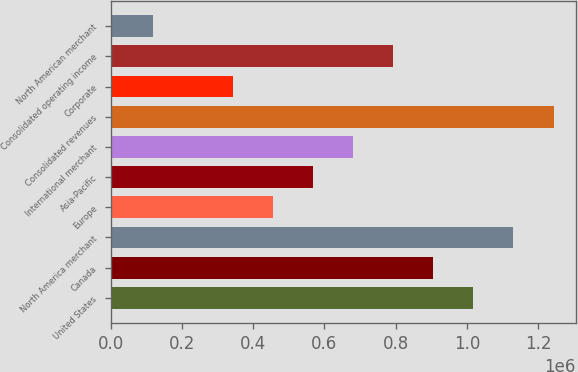Convert chart. <chart><loc_0><loc_0><loc_500><loc_500><bar_chart><fcel>United States<fcel>Canada<fcel>North America merchant<fcel>Europe<fcel>Asia-Pacific<fcel>International merchant<fcel>Consolidated revenues<fcel>Corporate<fcel>Consolidated operating income<fcel>North American merchant<nl><fcel>1.01807e+06<fcel>905525<fcel>1.13061e+06<fcel>455358<fcel>567900<fcel>680442<fcel>1.24315e+06<fcel>342817<fcel>792983<fcel>117734<nl></chart> 